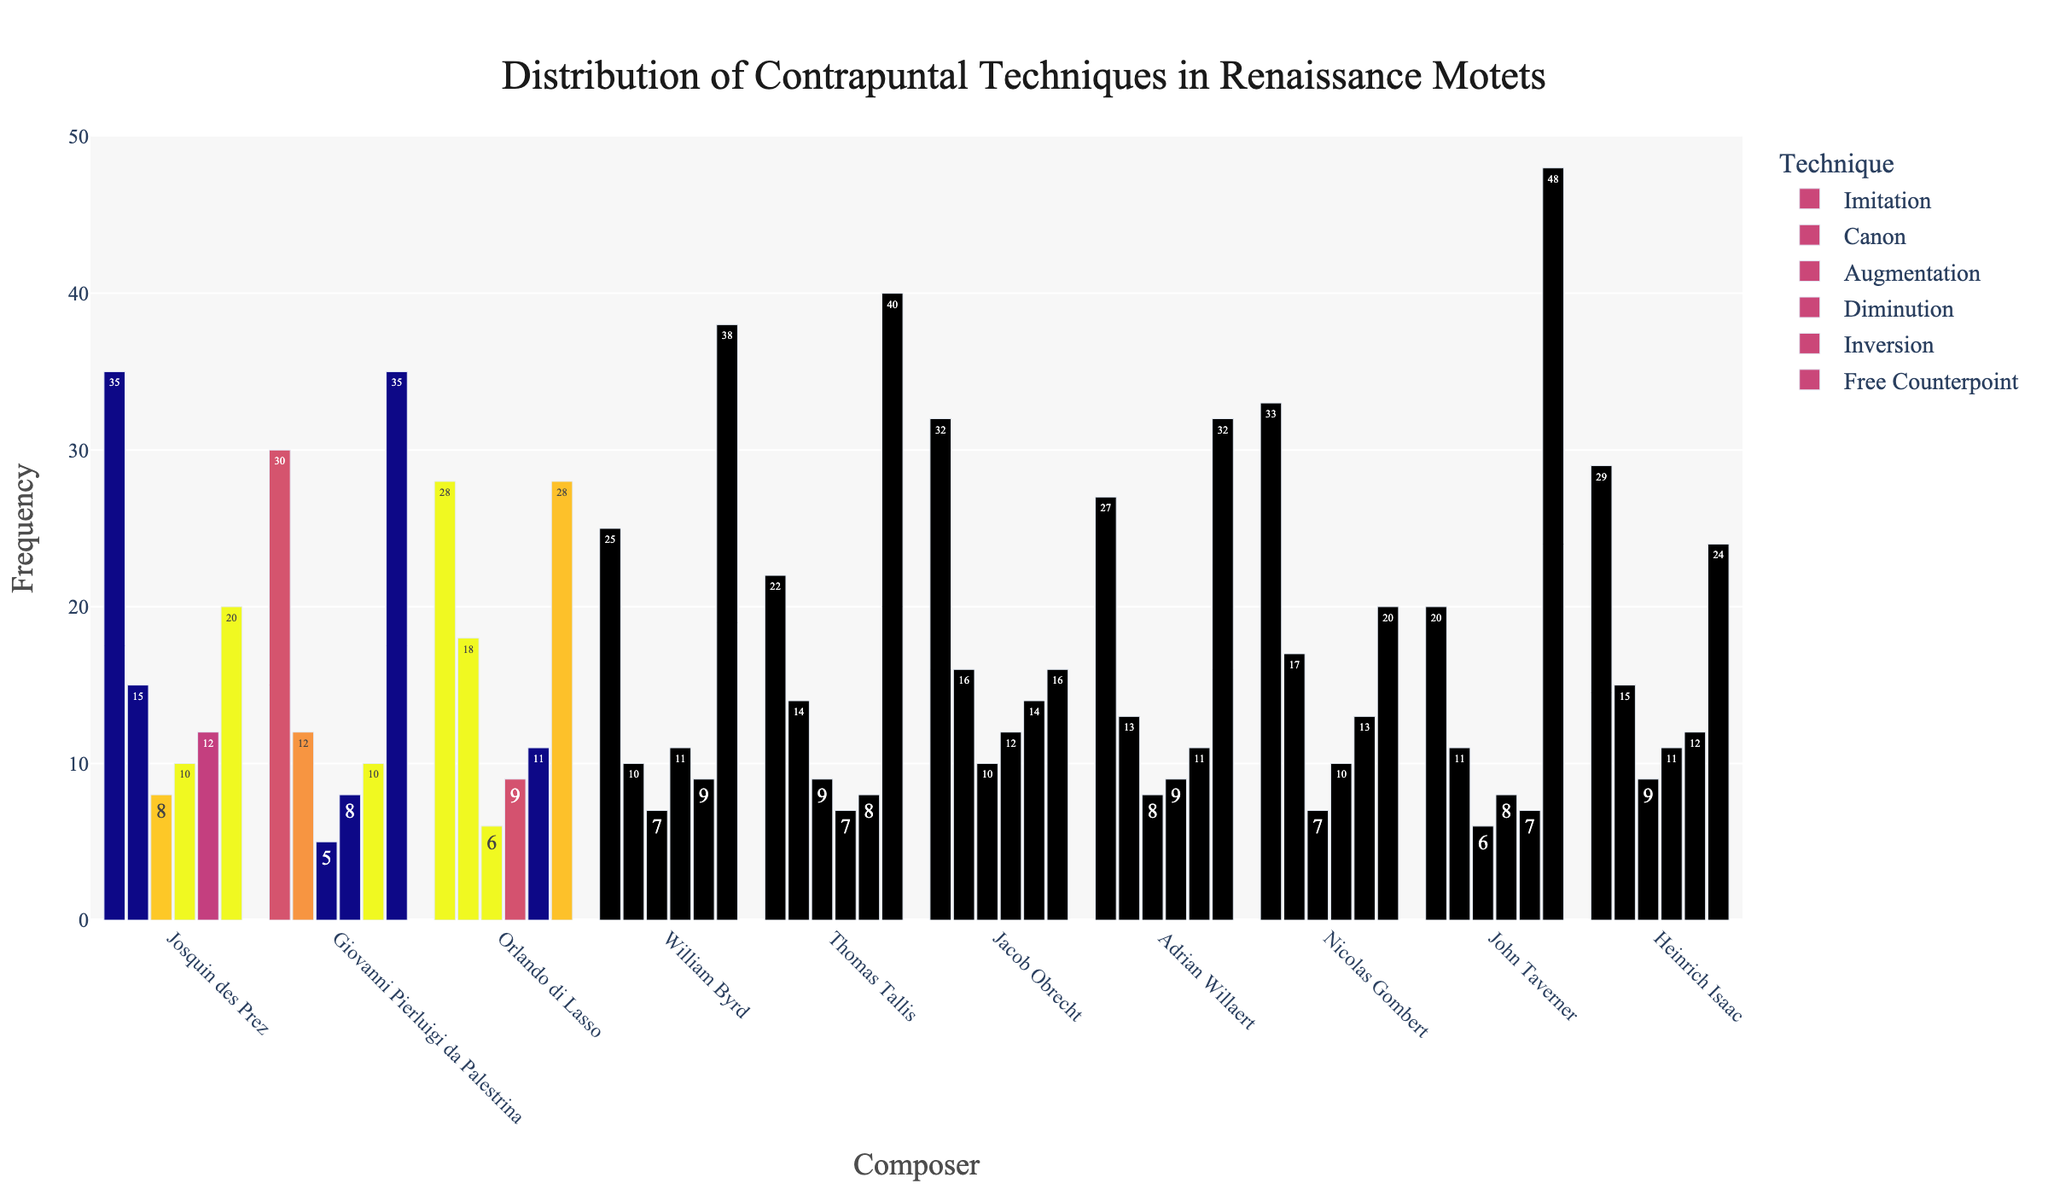Which composer used the highest number of free counterpoint techniques? By examining the bar chart, we look for the tallest bar corresponding to "Free Counterpoint". John Taverner has the highest bar in this category.
Answer: John Taverner Which two composers have the same number of canons? Look at the "Canon" bars for each composer and identify which are of equal height: Josquin des Prez and Heinrich Isaac both have the same height bar for "Canon".
Answer: Josquin des Prez and Heinrich Isaac What is the difference in the number of imitations between William Byrd and Thomas Tallis? Check the bar lengths for "Imitation" for both composers: William Byrd has 25 and Thomas Tallis has 22. Subtract the smaller value from the larger one: 25 - 22.
Answer: 3 Which technique is used most frequently by Giovanni Pierluigi da Palestrina? Identify the tallest bar in Giovanni Pierluigi da Palestrina's section: "Free Counterpoint" has the tallest bar.
Answer: Free Counterpoint What is the combined total of augmentations for Nicolas Gombert and Jacob Obrecht? Add the values for "Augmentation" of both composers: Nicolas Gombert (7) + Jacob Obrecht (10). Sum them up: 7 + 10.
Answer: 17 Who used inversion the least and what is that number? Combing through the "Inversion" bars for each composer, Thomas Tallis has the shortest bar. The corresponding number is 8.
Answer: Thomas Tallis, 8 Which two composers have the closest number of diminutions? Comparing the "Diminution" bars, Giovanni Pierluigi da Palestrina and Adrian Willaert both have bars that are very close in height: 8 each.
Answer: Giovanni Pierluigi da Palestrina and Adrian Willaert What's the average number of canons used by all composers? Calculate the sum of the "Canon" values and divide by the number of composers: (15 + 12 + 18 + 10 + 14 + 16 + 13 + 17 + 11 + 15) / 10. Performing the calculations, the sum is 141 and the average is 141/10.
Answer: 14.1 Which composer exhibits the greatest variation in the frequency of contrapuntal techniques? By assessing the range (difference between maximum and minimum values) within each composer's section, John Taverner ranges from 48 in "Free Counterpoint" to 6 in "Canon". The difference is 48 - 6 = 42, which is higher than any other composer.
Answer: John Taverner How many contrapuntal techniques have exactly the same frequency for Orlando di Lasso? By examining the heights of the bars for Orlando di Lasso, we see that no two bars have the exact same height.
Answer: 0 